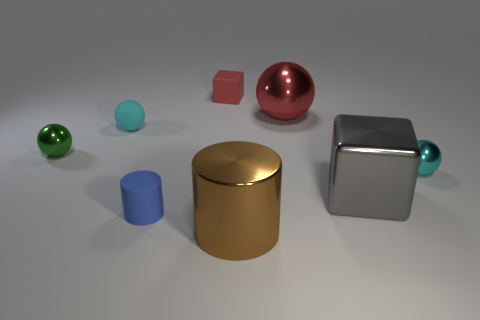What number of other things are there of the same size as the brown cylinder?
Keep it short and to the point. 2. The metallic sphere that is the same color as the small matte ball is what size?
Ensure brevity in your answer.  Small. There is a metallic thing to the left of the small cube; is its shape the same as the cyan shiny object?
Provide a succinct answer. Yes. How many other objects are the same shape as the cyan rubber thing?
Make the answer very short. 3. There is a cyan object that is to the right of the blue matte thing; what is its shape?
Your answer should be compact. Sphere. Is there another blue cylinder that has the same material as the small blue cylinder?
Your answer should be very brief. No. There is a tiny ball on the right side of the tiny red rubber object; is it the same color as the rubber ball?
Make the answer very short. Yes. The matte cylinder is what size?
Give a very brief answer. Small. Is there a cyan rubber object in front of the big metallic object that is behind the sphere that is to the left of the rubber ball?
Make the answer very short. Yes. What number of cylinders are to the right of the small red rubber thing?
Ensure brevity in your answer.  1. 